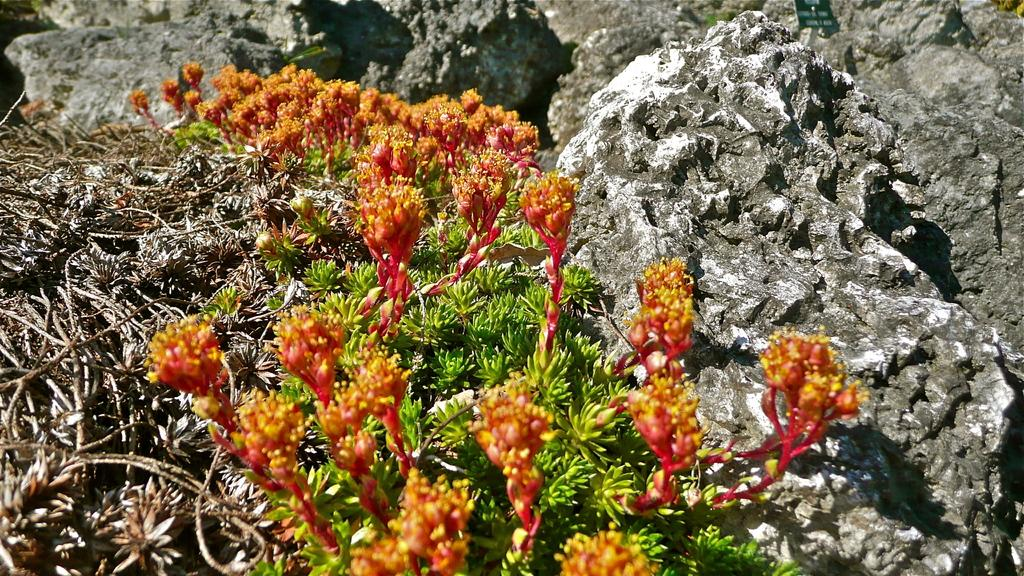What type of flora is present in the image? There are flowers on the plants in the image. What other elements can be seen in the image? There are rocks in the image. What type of trade is being conducted in the image? There is no indication of any trade being conducted in the image. What type of basket is visible in the image? There is no basket present in the image. 